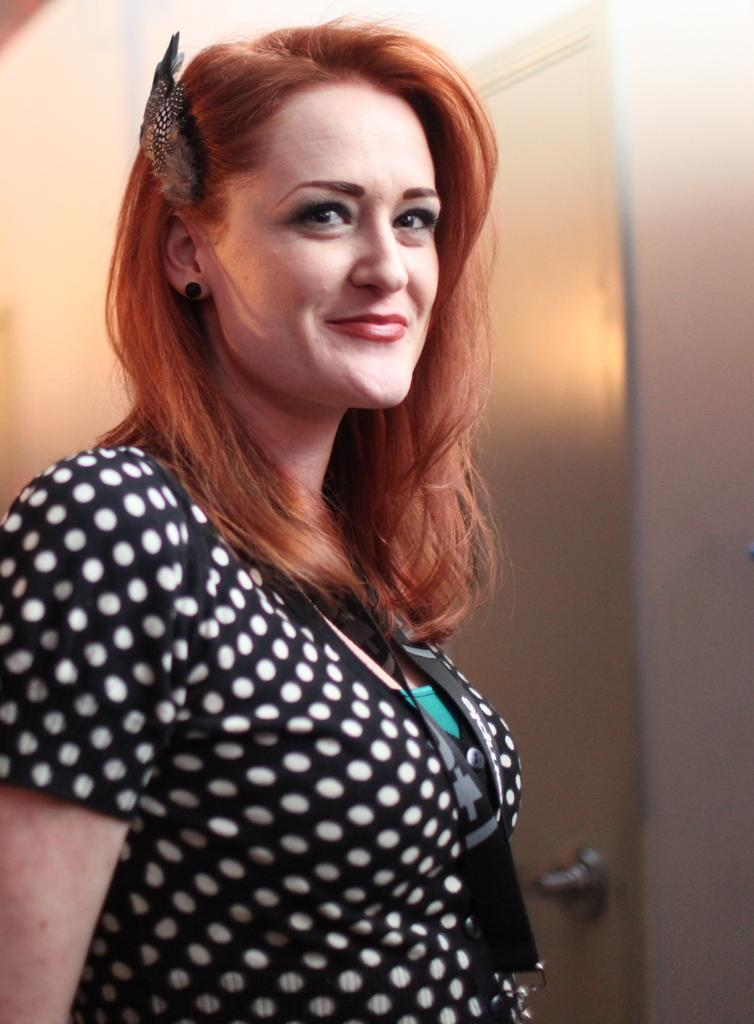Who is present in the image? There is a woman in the image. What is the woman wearing? The woman is wearing a black and white dress. What is the woman doing in the image? The woman is standing. What can be seen in the background of the image? There is a door in the background of the image. What type of vessel is the woman using to navigate the waters in the image? There is no vessel present in the image, nor is there any indication of water or navigation. 